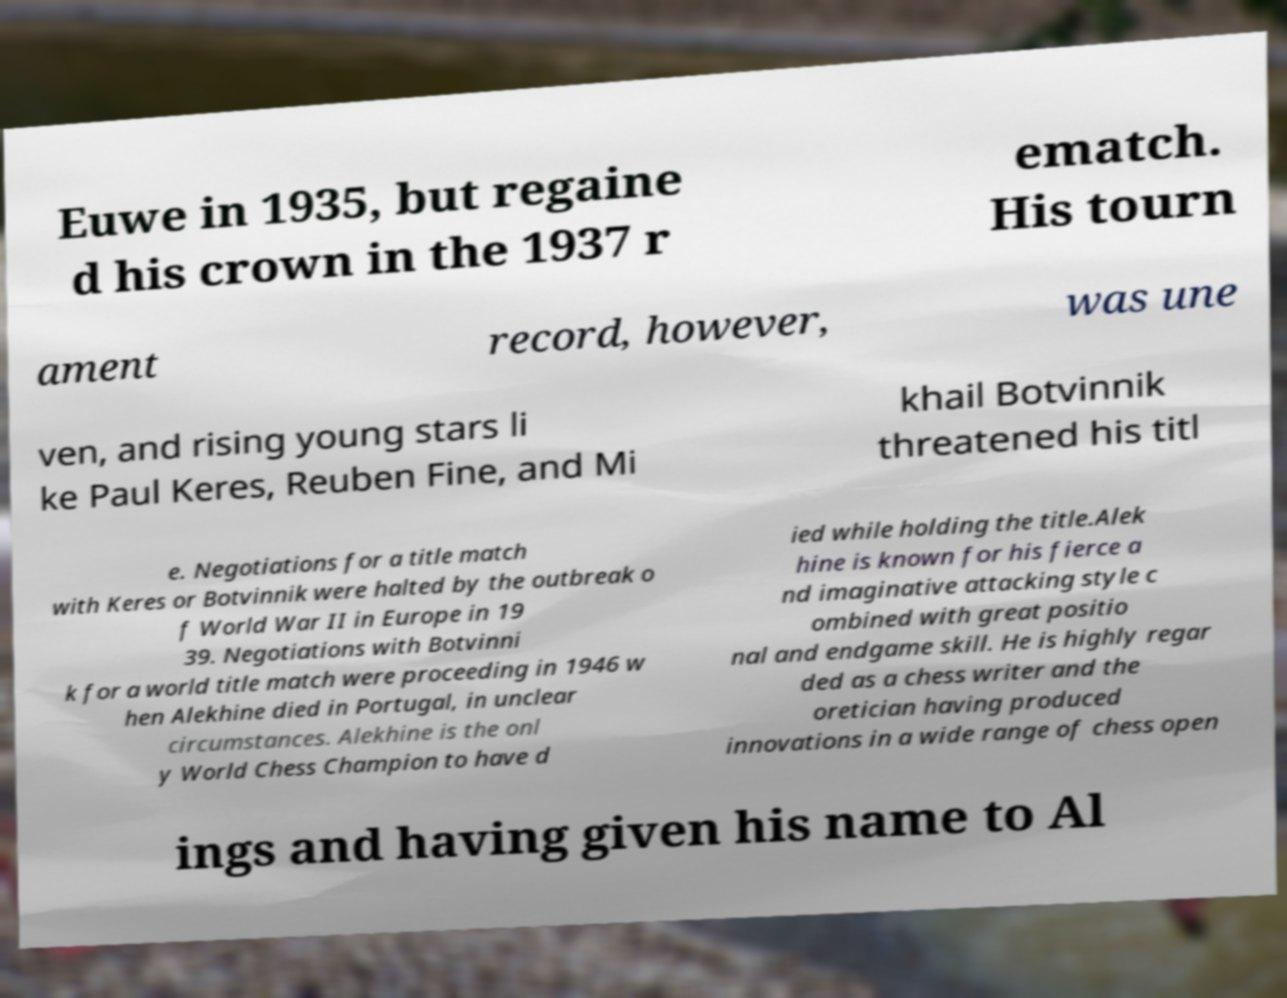What messages or text are displayed in this image? I need them in a readable, typed format. Euwe in 1935, but regaine d his crown in the 1937 r ematch. His tourn ament record, however, was une ven, and rising young stars li ke Paul Keres, Reuben Fine, and Mi khail Botvinnik threatened his titl e. Negotiations for a title match with Keres or Botvinnik were halted by the outbreak o f World War II in Europe in 19 39. Negotiations with Botvinni k for a world title match were proceeding in 1946 w hen Alekhine died in Portugal, in unclear circumstances. Alekhine is the onl y World Chess Champion to have d ied while holding the title.Alek hine is known for his fierce a nd imaginative attacking style c ombined with great positio nal and endgame skill. He is highly regar ded as a chess writer and the oretician having produced innovations in a wide range of chess open ings and having given his name to Al 